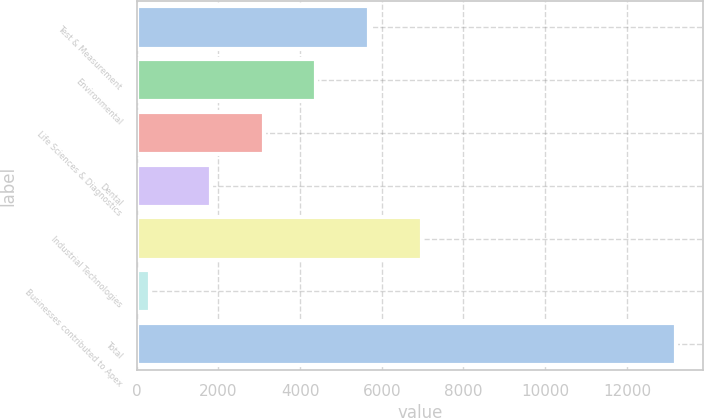<chart> <loc_0><loc_0><loc_500><loc_500><bar_chart><fcel>Test & Measurement<fcel>Environmental<fcel>Life Sciences & Diagnostics<fcel>Dental<fcel>Industrial Technologies<fcel>Businesses contributed to Apex<fcel>Total<nl><fcel>5690.7<fcel>4402<fcel>3113.3<fcel>1824.6<fcel>6979.4<fcel>315.6<fcel>13202.6<nl></chart> 